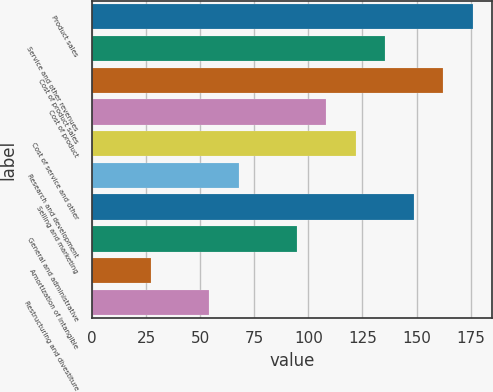Convert chart. <chart><loc_0><loc_0><loc_500><loc_500><bar_chart><fcel>Product sales<fcel>Service and other revenues<fcel>Cost of product sales<fcel>Cost of product<fcel>Cost of service and other<fcel>Research and development<fcel>Selling and marketing<fcel>General and administrative<fcel>Amortization of intangible<fcel>Restructuring and divestiture<nl><fcel>175.99<fcel>135.4<fcel>162.46<fcel>108.34<fcel>121.87<fcel>67.75<fcel>148.93<fcel>94.81<fcel>27.16<fcel>54.22<nl></chart> 